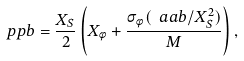<formula> <loc_0><loc_0><loc_500><loc_500>\ p p b = \frac { X _ { S } } { 2 } \left ( X _ { \phi } + \frac { \sigma _ { \phi } ( \ a a b / X _ { S } ^ { 2 } ) } { M } \right ) ,</formula> 